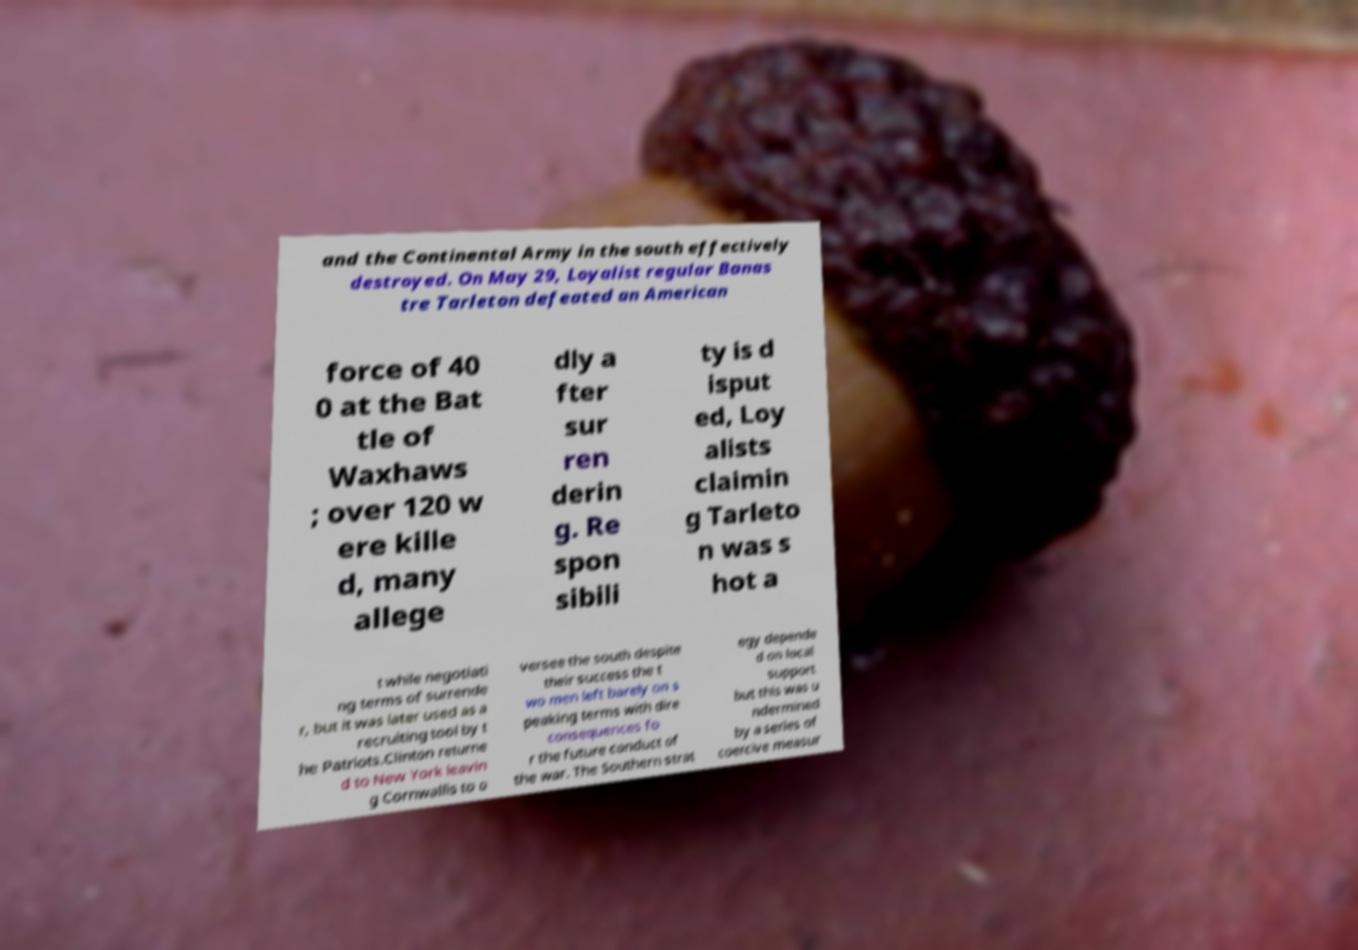For documentation purposes, I need the text within this image transcribed. Could you provide that? and the Continental Army in the south effectively destroyed. On May 29, Loyalist regular Banas tre Tarleton defeated an American force of 40 0 at the Bat tle of Waxhaws ; over 120 w ere kille d, many allege dly a fter sur ren derin g. Re spon sibili ty is d isput ed, Loy alists claimin g Tarleto n was s hot a t while negotiati ng terms of surrende r, but it was later used as a recruiting tool by t he Patriots.Clinton returne d to New York leavin g Cornwallis to o versee the south despite their success the t wo men left barely on s peaking terms with dire consequences fo r the future conduct of the war. The Southern strat egy depende d on local support but this was u ndermined by a series of coercive measur 